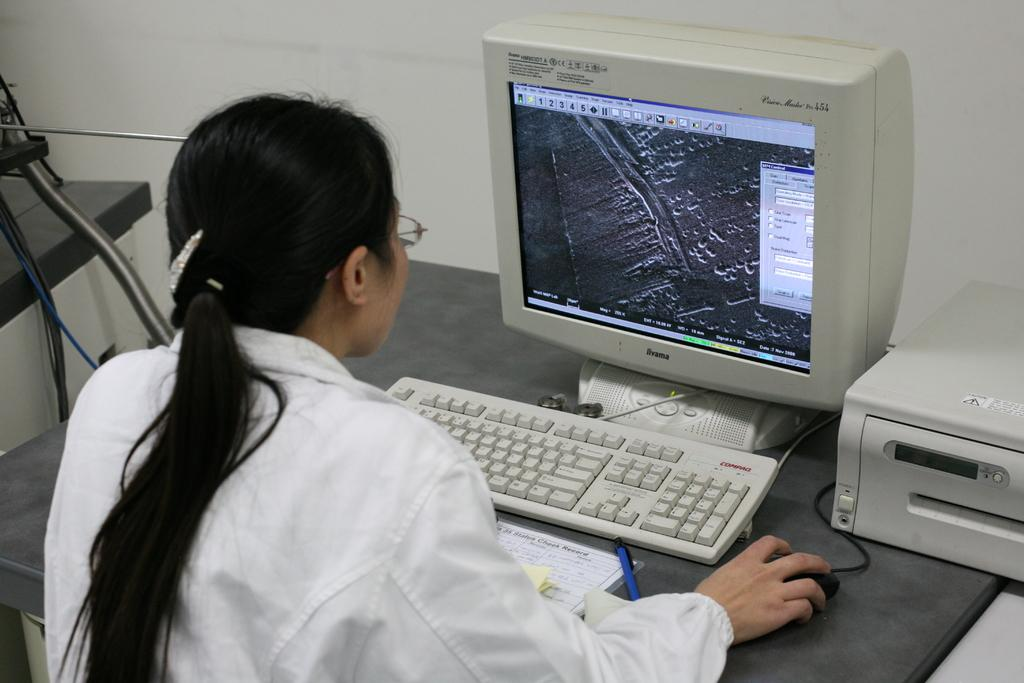Who is present in the image? There is a woman in the image. What is the woman holding in the image? The woman is holding a mouse, likely a computer mouse. What electronic devices are visible in the image? There is a computer and a keyboard in the image. What type of furniture is present in the image? There is a bench in the image. How many frogs can be seen on the computer screen in the image? There are no frogs visible on the computer screen in the image. What type of error message is displayed on the computer screen in the image? There is no error message displayed on the computer screen in the image. 